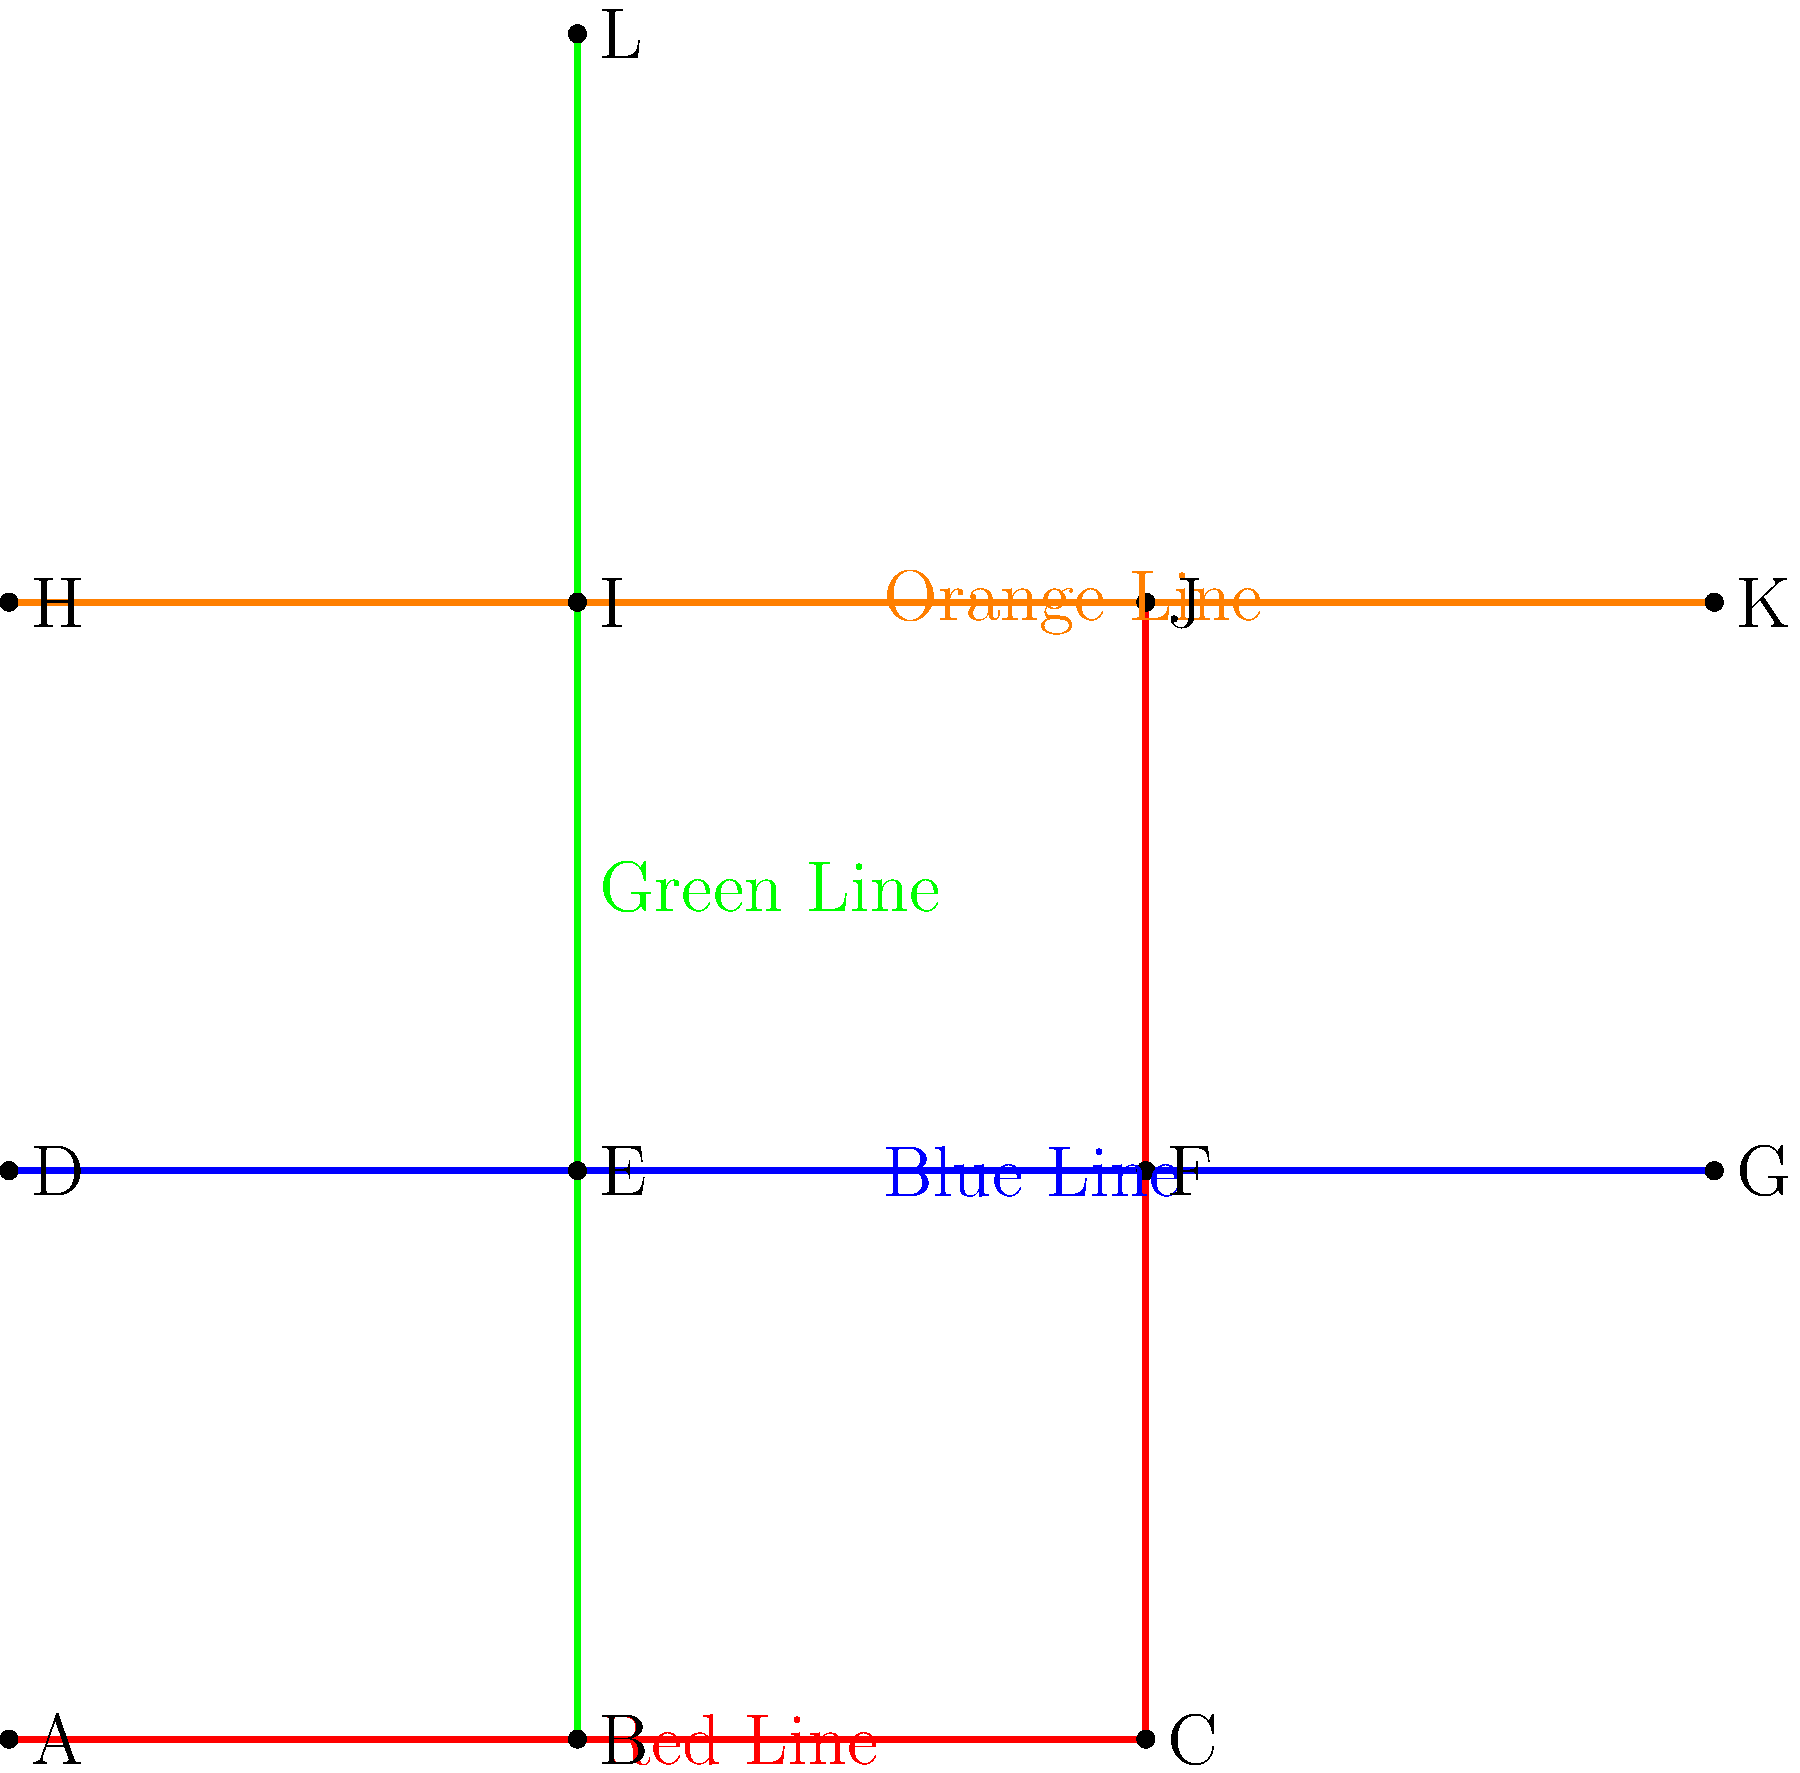You need to travel from station A to station K using the subway system shown in the map. What is the minimum number of line changes required to reach your destination? Let's analyze the possible routes from station A to station K:

1. Start at station A on the Red Line.
2. The Red Line doesn't directly connect to station K.
3. We need to change lines at least once.
4. Possible routes:
   a. Red Line (A to C) -> Orange Line (J to K): 1 change
   b. Red Line (A to B) -> Green Line (B to I) -> Orange Line (I to K): 2 changes
   c. Red Line (A to C) -> Blue Line (F to G) -> Orange Line (K): 2 changes

5. The route with the minimum number of line changes is option a, which requires only 1 change.

Therefore, the minimum number of line changes required to travel from station A to station K is 1.
Answer: 1 